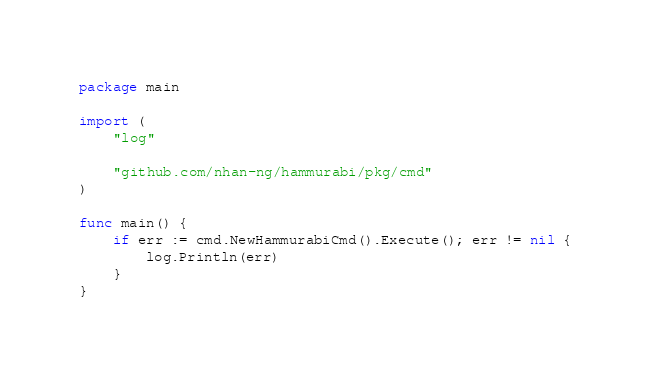Convert code to text. <code><loc_0><loc_0><loc_500><loc_500><_Go_>package main

import (
	"log"

	"github.com/nhan-ng/hammurabi/pkg/cmd"
)

func main() {
	if err := cmd.NewHammurabiCmd().Execute(); err != nil {
		log.Println(err)
	}
}
</code> 